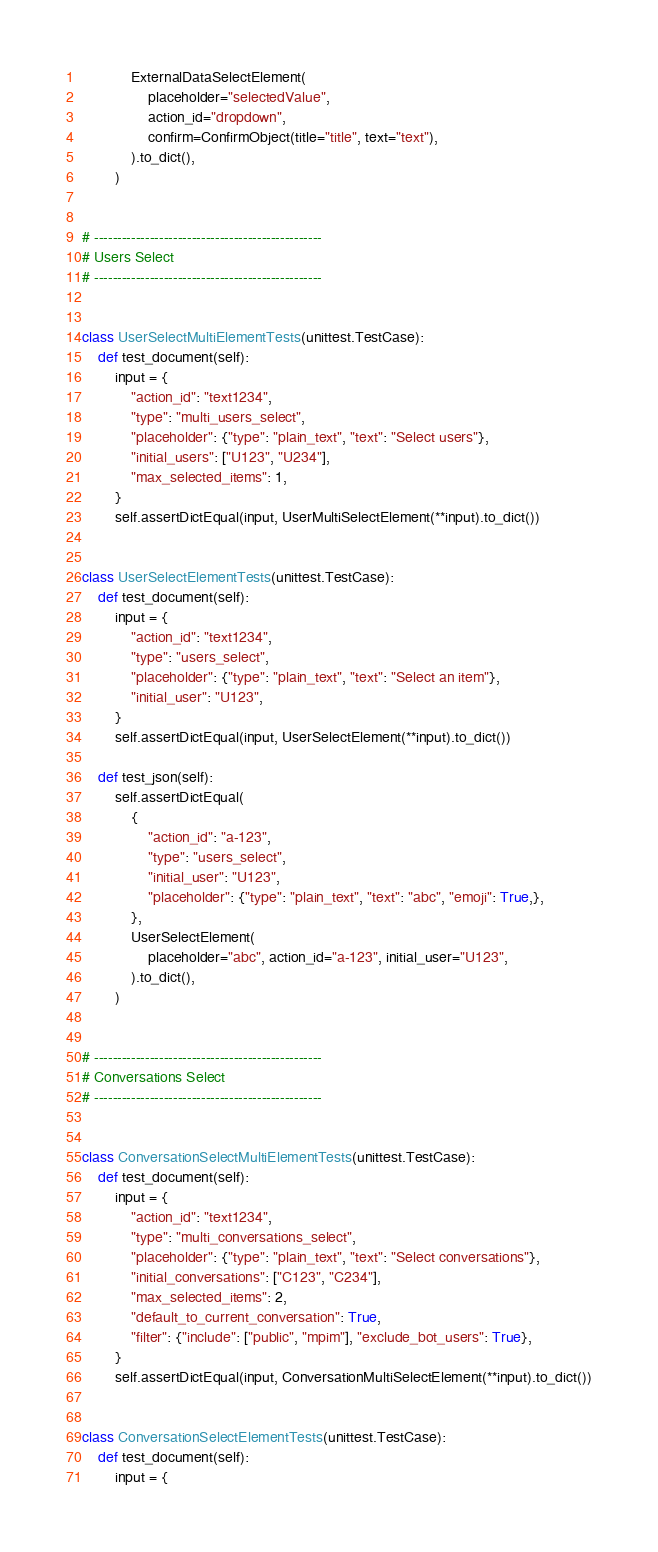<code> <loc_0><loc_0><loc_500><loc_500><_Python_>            ExternalDataSelectElement(
                placeholder="selectedValue",
                action_id="dropdown",
                confirm=ConfirmObject(title="title", text="text"),
            ).to_dict(),
        )


# -------------------------------------------------
# Users Select
# -------------------------------------------------


class UserSelectMultiElementTests(unittest.TestCase):
    def test_document(self):
        input = {
            "action_id": "text1234",
            "type": "multi_users_select",
            "placeholder": {"type": "plain_text", "text": "Select users"},
            "initial_users": ["U123", "U234"],
            "max_selected_items": 1,
        }
        self.assertDictEqual(input, UserMultiSelectElement(**input).to_dict())


class UserSelectElementTests(unittest.TestCase):
    def test_document(self):
        input = {
            "action_id": "text1234",
            "type": "users_select",
            "placeholder": {"type": "plain_text", "text": "Select an item"},
            "initial_user": "U123",
        }
        self.assertDictEqual(input, UserSelectElement(**input).to_dict())

    def test_json(self):
        self.assertDictEqual(
            {
                "action_id": "a-123",
                "type": "users_select",
                "initial_user": "U123",
                "placeholder": {"type": "plain_text", "text": "abc", "emoji": True,},
            },
            UserSelectElement(
                placeholder="abc", action_id="a-123", initial_user="U123",
            ).to_dict(),
        )


# -------------------------------------------------
# Conversations Select
# -------------------------------------------------


class ConversationSelectMultiElementTests(unittest.TestCase):
    def test_document(self):
        input = {
            "action_id": "text1234",
            "type": "multi_conversations_select",
            "placeholder": {"type": "plain_text", "text": "Select conversations"},
            "initial_conversations": ["C123", "C234"],
            "max_selected_items": 2,
            "default_to_current_conversation": True,
            "filter": {"include": ["public", "mpim"], "exclude_bot_users": True},
        }
        self.assertDictEqual(input, ConversationMultiSelectElement(**input).to_dict())


class ConversationSelectElementTests(unittest.TestCase):
    def test_document(self):
        input = {</code> 